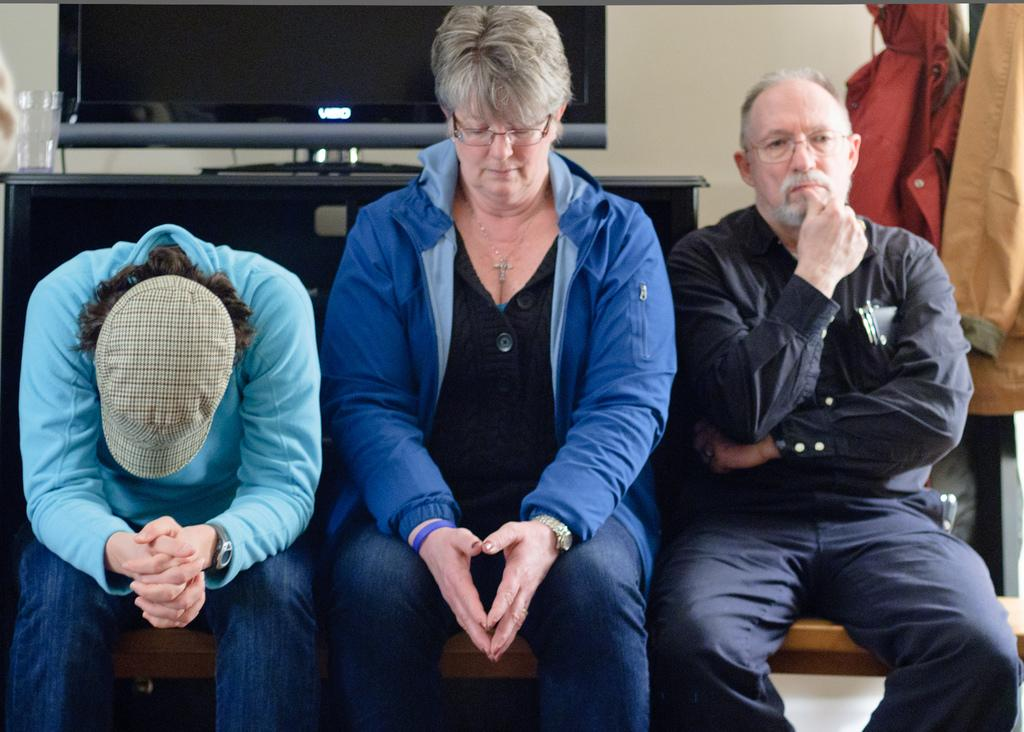How many people are sitting in the image? There are three people sitting in the image. Can you describe the clothing of the person on the left? The person on the left is wearing a cap. What object can be seen in the image that is typically used for drinking? There is a glass in the image. What type of electronic device is present in the image? There is a television in the image. Where are the coats located in the image? The coats are hanging on the right side of the image. How many faucets are visible in the image? There are no faucets visible in the image. What type of meat is being prepared on the television in the image? There is no meat being prepared in the image, and the television is an electronic device, not a cooking appliance. 